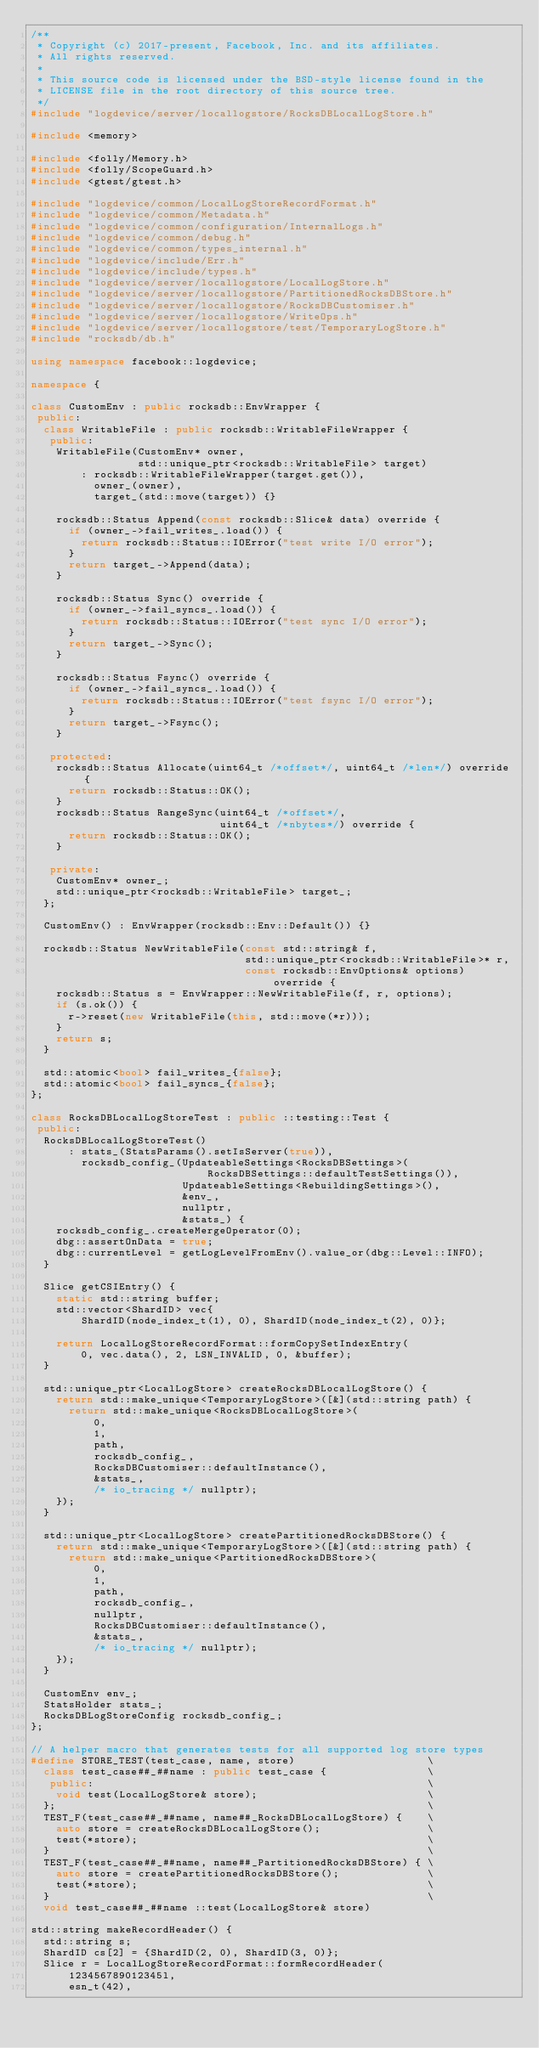<code> <loc_0><loc_0><loc_500><loc_500><_C++_>/**
 * Copyright (c) 2017-present, Facebook, Inc. and its affiliates.
 * All rights reserved.
 *
 * This source code is licensed under the BSD-style license found in the
 * LICENSE file in the root directory of this source tree.
 */
#include "logdevice/server/locallogstore/RocksDBLocalLogStore.h"

#include <memory>

#include <folly/Memory.h>
#include <folly/ScopeGuard.h>
#include <gtest/gtest.h>

#include "logdevice/common/LocalLogStoreRecordFormat.h"
#include "logdevice/common/Metadata.h"
#include "logdevice/common/configuration/InternalLogs.h"
#include "logdevice/common/debug.h"
#include "logdevice/common/types_internal.h"
#include "logdevice/include/Err.h"
#include "logdevice/include/types.h"
#include "logdevice/server/locallogstore/LocalLogStore.h"
#include "logdevice/server/locallogstore/PartitionedRocksDBStore.h"
#include "logdevice/server/locallogstore/RocksDBCustomiser.h"
#include "logdevice/server/locallogstore/WriteOps.h"
#include "logdevice/server/locallogstore/test/TemporaryLogStore.h"
#include "rocksdb/db.h"

using namespace facebook::logdevice;

namespace {

class CustomEnv : public rocksdb::EnvWrapper {
 public:
  class WritableFile : public rocksdb::WritableFileWrapper {
   public:
    WritableFile(CustomEnv* owner,
                 std::unique_ptr<rocksdb::WritableFile> target)
        : rocksdb::WritableFileWrapper(target.get()),
          owner_(owner),
          target_(std::move(target)) {}

    rocksdb::Status Append(const rocksdb::Slice& data) override {
      if (owner_->fail_writes_.load()) {
        return rocksdb::Status::IOError("test write I/O error");
      }
      return target_->Append(data);
    }

    rocksdb::Status Sync() override {
      if (owner_->fail_syncs_.load()) {
        return rocksdb::Status::IOError("test sync I/O error");
      }
      return target_->Sync();
    }

    rocksdb::Status Fsync() override {
      if (owner_->fail_syncs_.load()) {
        return rocksdb::Status::IOError("test fsync I/O error");
      }
      return target_->Fsync();
    }

   protected:
    rocksdb::Status Allocate(uint64_t /*offset*/, uint64_t /*len*/) override {
      return rocksdb::Status::OK();
    }
    rocksdb::Status RangeSync(uint64_t /*offset*/,
                              uint64_t /*nbytes*/) override {
      return rocksdb::Status::OK();
    }

   private:
    CustomEnv* owner_;
    std::unique_ptr<rocksdb::WritableFile> target_;
  };

  CustomEnv() : EnvWrapper(rocksdb::Env::Default()) {}

  rocksdb::Status NewWritableFile(const std::string& f,
                                  std::unique_ptr<rocksdb::WritableFile>* r,
                                  const rocksdb::EnvOptions& options) override {
    rocksdb::Status s = EnvWrapper::NewWritableFile(f, r, options);
    if (s.ok()) {
      r->reset(new WritableFile(this, std::move(*r)));
    }
    return s;
  }

  std::atomic<bool> fail_writes_{false};
  std::atomic<bool> fail_syncs_{false};
};

class RocksDBLocalLogStoreTest : public ::testing::Test {
 public:
  RocksDBLocalLogStoreTest()
      : stats_(StatsParams().setIsServer(true)),
        rocksdb_config_(UpdateableSettings<RocksDBSettings>(
                            RocksDBSettings::defaultTestSettings()),
                        UpdateableSettings<RebuildingSettings>(),
                        &env_,
                        nullptr,
                        &stats_) {
    rocksdb_config_.createMergeOperator(0);
    dbg::assertOnData = true;
    dbg::currentLevel = getLogLevelFromEnv().value_or(dbg::Level::INFO);
  }

  Slice getCSIEntry() {
    static std::string buffer;
    std::vector<ShardID> vec{
        ShardID(node_index_t(1), 0), ShardID(node_index_t(2), 0)};

    return LocalLogStoreRecordFormat::formCopySetIndexEntry(
        0, vec.data(), 2, LSN_INVALID, 0, &buffer);
  }

  std::unique_ptr<LocalLogStore> createRocksDBLocalLogStore() {
    return std::make_unique<TemporaryLogStore>([&](std::string path) {
      return std::make_unique<RocksDBLocalLogStore>(
          0,
          1,
          path,
          rocksdb_config_,
          RocksDBCustomiser::defaultInstance(),
          &stats_,
          /* io_tracing */ nullptr);
    });
  }

  std::unique_ptr<LocalLogStore> createPartitionedRocksDBStore() {
    return std::make_unique<TemporaryLogStore>([&](std::string path) {
      return std::make_unique<PartitionedRocksDBStore>(
          0,
          1,
          path,
          rocksdb_config_,
          nullptr,
          RocksDBCustomiser::defaultInstance(),
          &stats_,
          /* io_tracing */ nullptr);
    });
  }

  CustomEnv env_;
  StatsHolder stats_;
  RocksDBLogStoreConfig rocksdb_config_;
};

// A helper macro that generates tests for all supported log store types
#define STORE_TEST(test_case, name, store)                     \
  class test_case##_##name : public test_case {                \
   public:                                                     \
    void test(LocalLogStore& store);                           \
  };                                                           \
  TEST_F(test_case##_##name, name##_RocksDBLocalLogStore) {    \
    auto store = createRocksDBLocalLogStore();                 \
    test(*store);                                              \
  }                                                            \
  TEST_F(test_case##_##name, name##_PartitionedRocksDBStore) { \
    auto store = createPartitionedRocksDBStore();              \
    test(*store);                                              \
  }                                                            \
  void test_case##_##name ::test(LocalLogStore& store)

std::string makeRecordHeader() {
  std::string s;
  ShardID cs[2] = {ShardID(2, 0), ShardID(3, 0)};
  Slice r = LocalLogStoreRecordFormat::formRecordHeader(
      123456789012345l,
      esn_t(42),</code> 